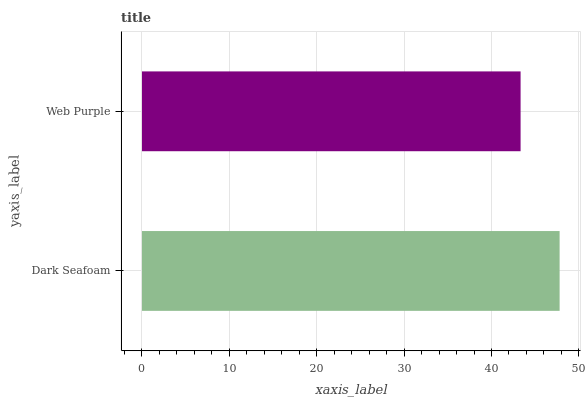Is Web Purple the minimum?
Answer yes or no. Yes. Is Dark Seafoam the maximum?
Answer yes or no. Yes. Is Web Purple the maximum?
Answer yes or no. No. Is Dark Seafoam greater than Web Purple?
Answer yes or no. Yes. Is Web Purple less than Dark Seafoam?
Answer yes or no. Yes. Is Web Purple greater than Dark Seafoam?
Answer yes or no. No. Is Dark Seafoam less than Web Purple?
Answer yes or no. No. Is Dark Seafoam the high median?
Answer yes or no. Yes. Is Web Purple the low median?
Answer yes or no. Yes. Is Web Purple the high median?
Answer yes or no. No. Is Dark Seafoam the low median?
Answer yes or no. No. 